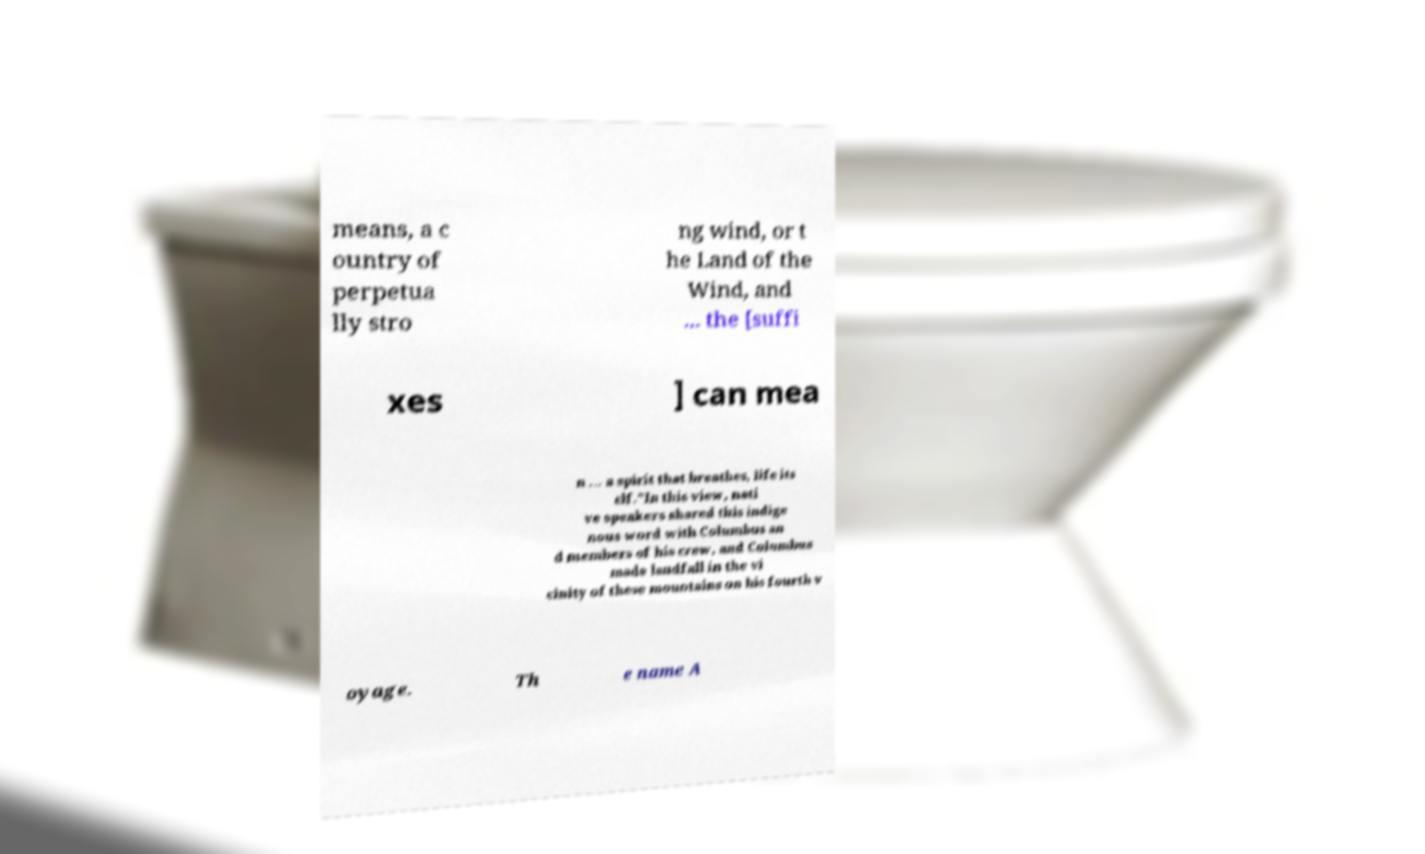Can you accurately transcribe the text from the provided image for me? means, a c ountry of perpetua lly stro ng wind, or t he Land of the Wind, and ... the [suffi xes ] can mea n ... a spirit that breathes, life its elf."In this view, nati ve speakers shared this indige nous word with Columbus an d members of his crew, and Columbus made landfall in the vi cinity of these mountains on his fourth v oyage. Th e name A 